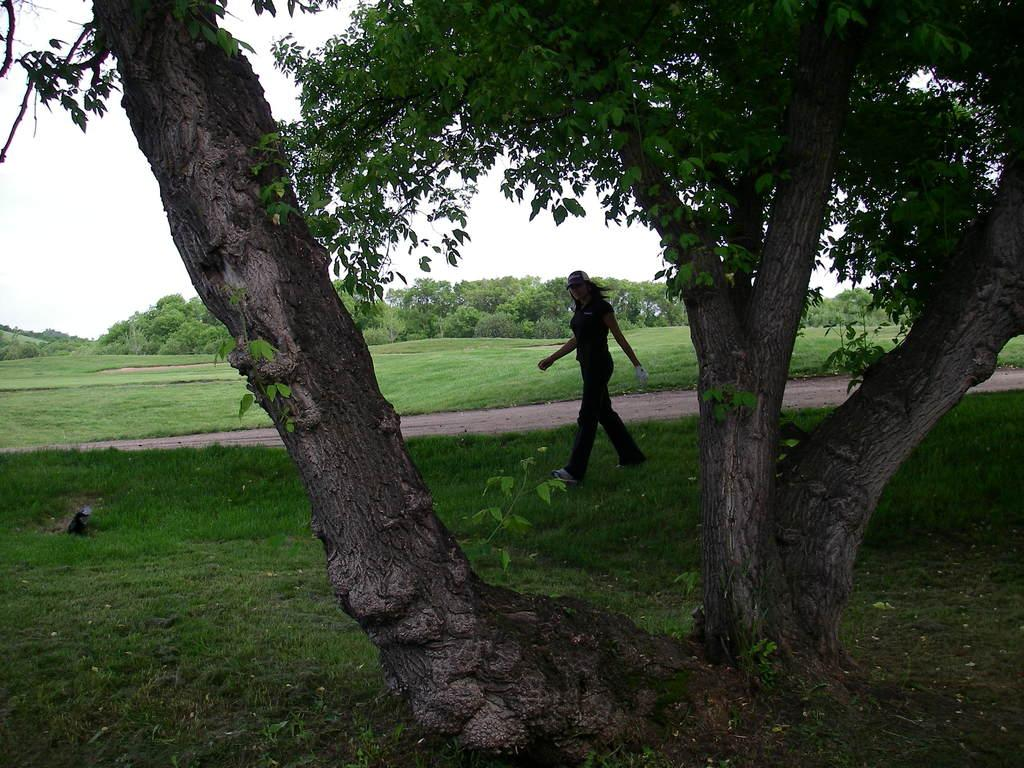How many people are in the image? There is one person in the image. What type of vegetation is present in the image? There are trees, plants, and grass in the image. What is visible at the top of the image? The sky is visible at the top of the image. What type of sheet is covering the plants in the image? There is no sheet present in the image; the plants are not covered. 